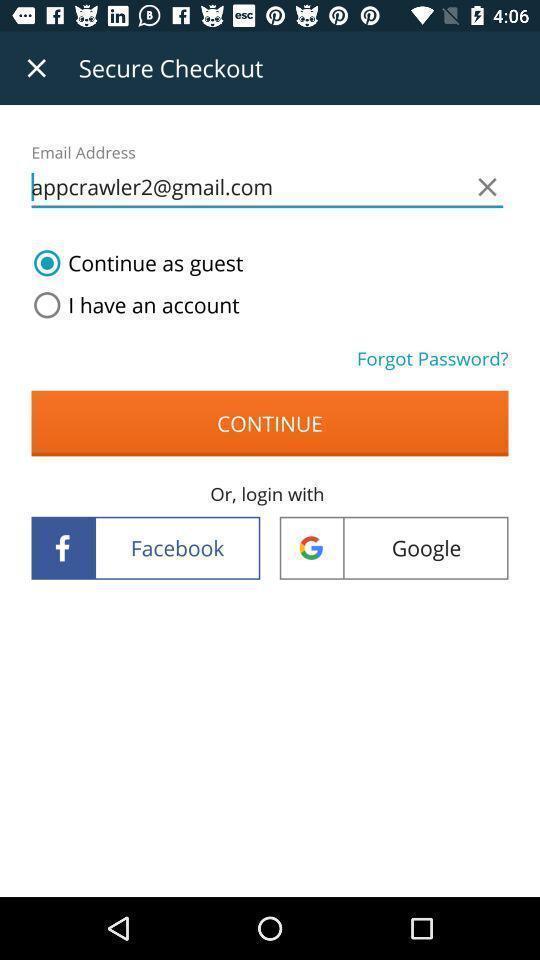What is the overall content of this screenshot? Welcome to the login page. 